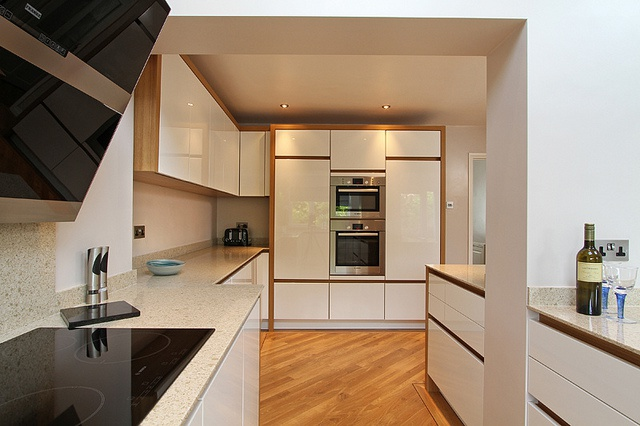Describe the objects in this image and their specific colors. I can see tv in black, gray, and maroon tones, oven in black and gray tones, oven in black, maroon, gray, and tan tones, bottle in black, olive, and beige tones, and microwave in black, gray, and darkgreen tones in this image. 